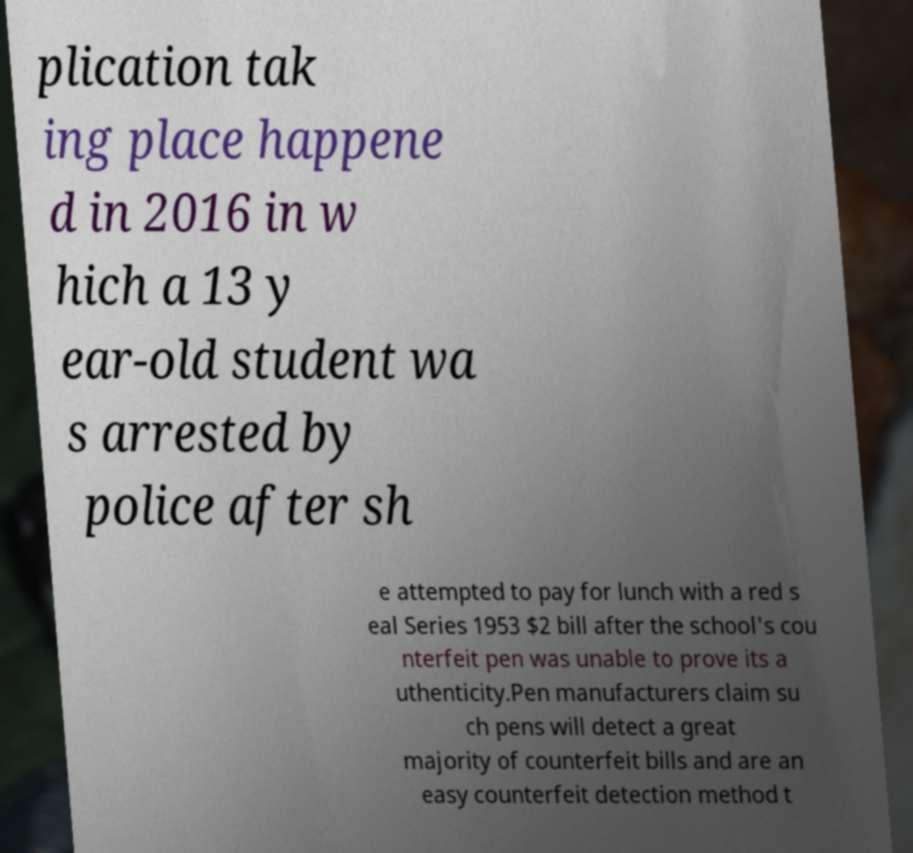What messages or text are displayed in this image? I need them in a readable, typed format. plication tak ing place happene d in 2016 in w hich a 13 y ear-old student wa s arrested by police after sh e attempted to pay for lunch with a red s eal Series 1953 $2 bill after the school's cou nterfeit pen was unable to prove its a uthenticity.Pen manufacturers claim su ch pens will detect a great majority of counterfeit bills and are an easy counterfeit detection method t 